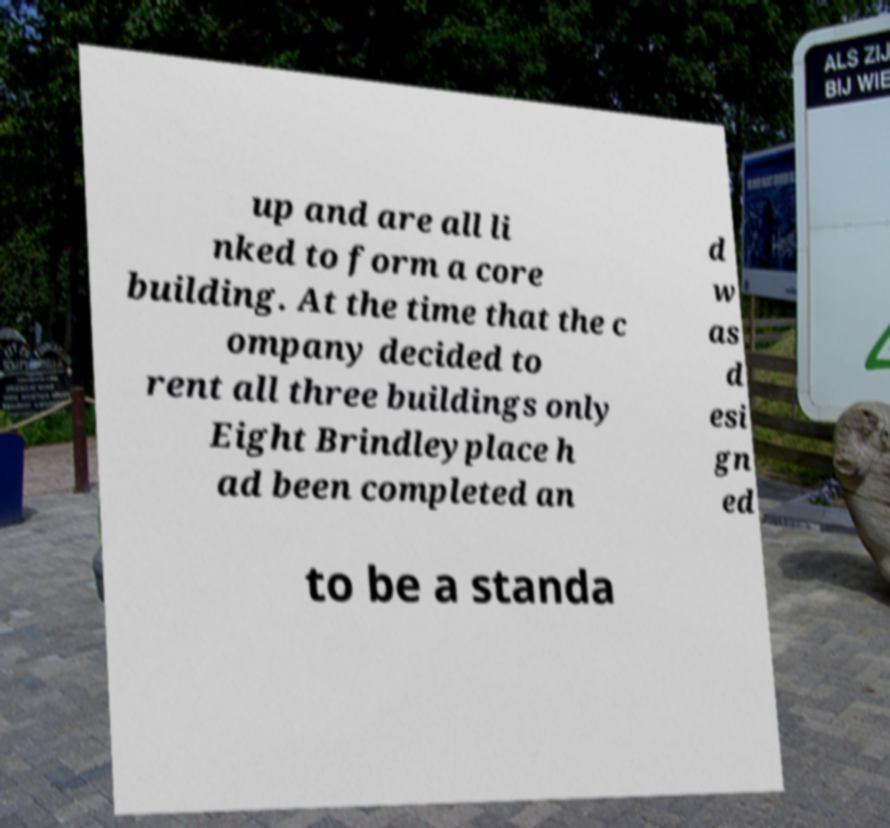Can you accurately transcribe the text from the provided image for me? up and are all li nked to form a core building. At the time that the c ompany decided to rent all three buildings only Eight Brindleyplace h ad been completed an d w as d esi gn ed to be a standa 